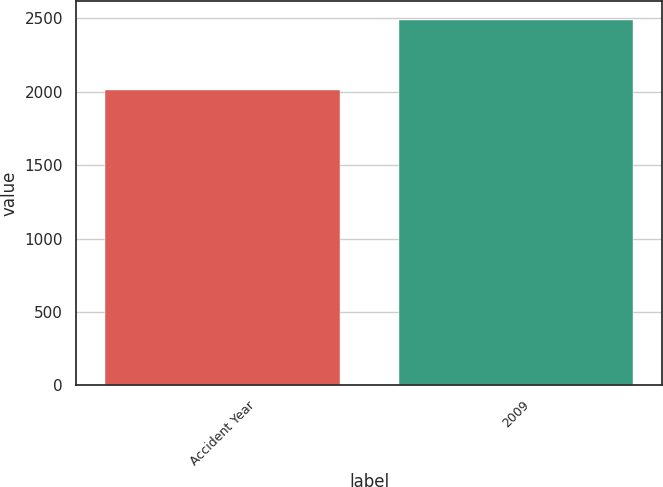Convert chart. <chart><loc_0><loc_0><loc_500><loc_500><bar_chart><fcel>Accident Year<fcel>2009<nl><fcel>2010<fcel>2491<nl></chart> 